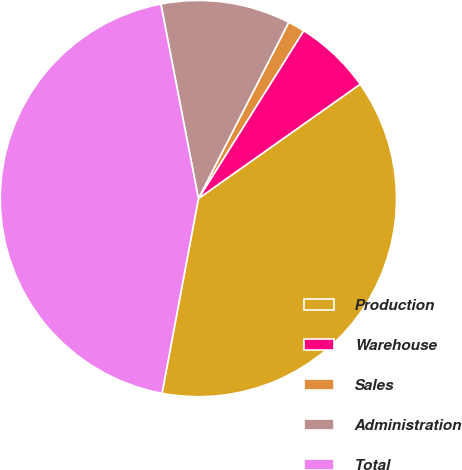<chart> <loc_0><loc_0><loc_500><loc_500><pie_chart><fcel>Production<fcel>Warehouse<fcel>Sales<fcel>Administration<fcel>Total<nl><fcel>37.74%<fcel>6.29%<fcel>1.38%<fcel>10.57%<fcel>44.03%<nl></chart> 